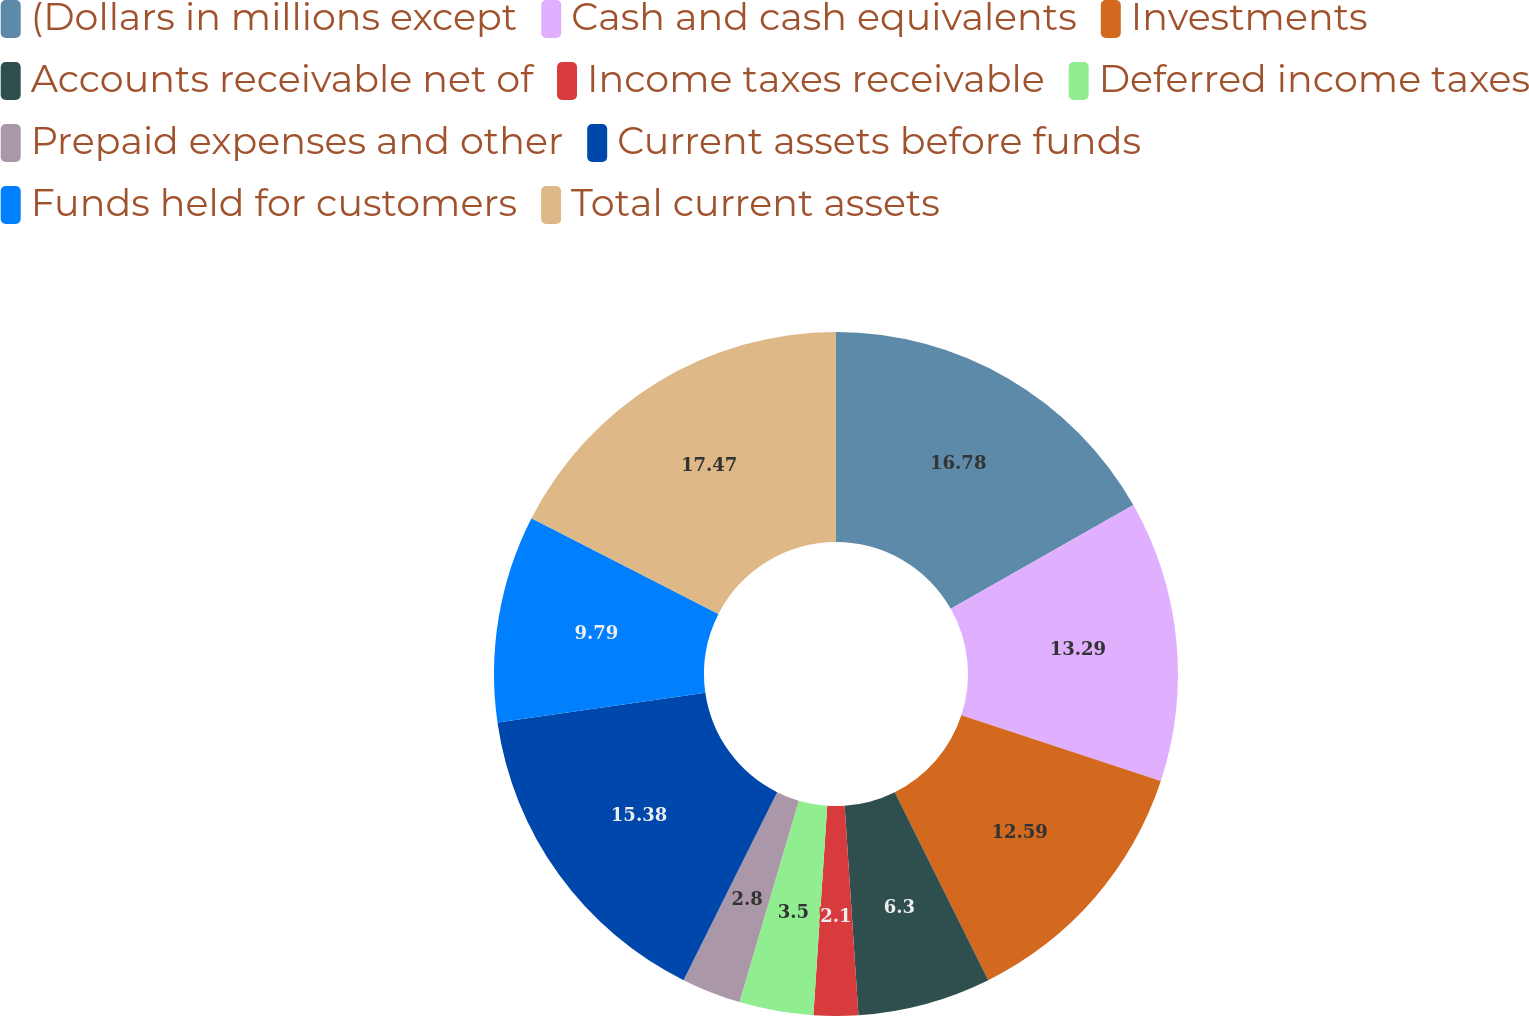<chart> <loc_0><loc_0><loc_500><loc_500><pie_chart><fcel>(Dollars in millions except<fcel>Cash and cash equivalents<fcel>Investments<fcel>Accounts receivable net of<fcel>Income taxes receivable<fcel>Deferred income taxes<fcel>Prepaid expenses and other<fcel>Current assets before funds<fcel>Funds held for customers<fcel>Total current assets<nl><fcel>16.78%<fcel>13.29%<fcel>12.59%<fcel>6.3%<fcel>2.1%<fcel>3.5%<fcel>2.8%<fcel>15.38%<fcel>9.79%<fcel>17.48%<nl></chart> 